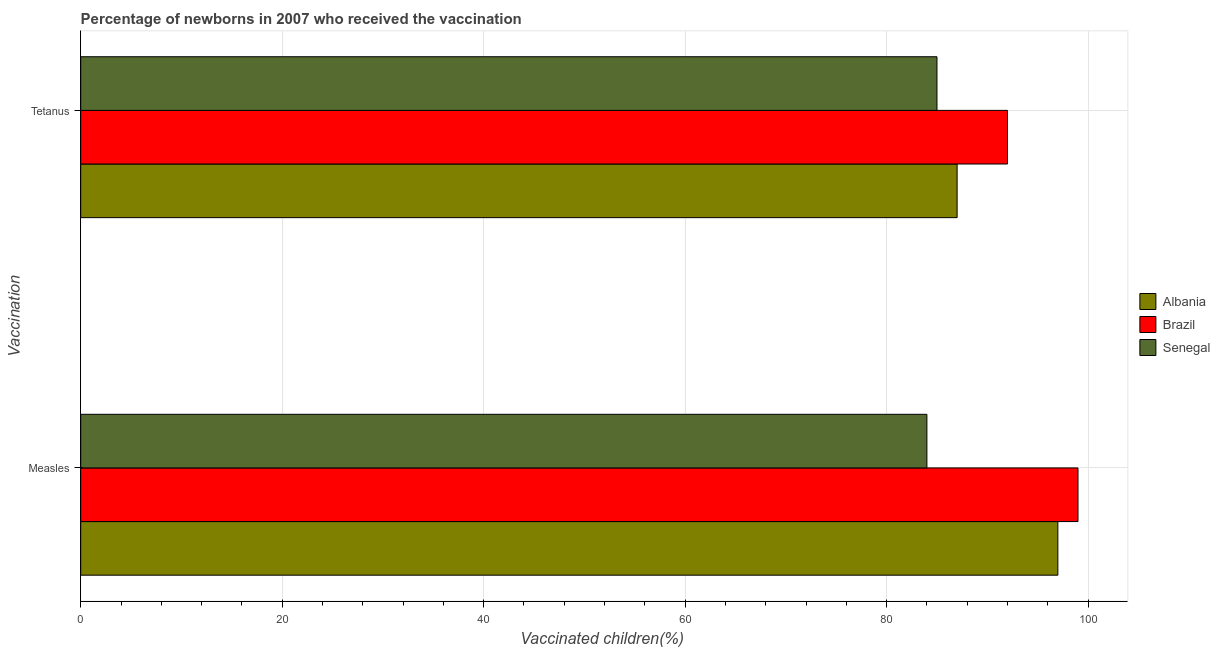Are the number of bars per tick equal to the number of legend labels?
Offer a very short reply. Yes. Are the number of bars on each tick of the Y-axis equal?
Your response must be concise. Yes. What is the label of the 1st group of bars from the top?
Give a very brief answer. Tetanus. What is the percentage of newborns who received vaccination for tetanus in Senegal?
Provide a short and direct response. 85. Across all countries, what is the maximum percentage of newborns who received vaccination for tetanus?
Offer a very short reply. 92. Across all countries, what is the minimum percentage of newborns who received vaccination for measles?
Your answer should be compact. 84. In which country was the percentage of newborns who received vaccination for measles maximum?
Keep it short and to the point. Brazil. In which country was the percentage of newborns who received vaccination for measles minimum?
Offer a terse response. Senegal. What is the total percentage of newborns who received vaccination for tetanus in the graph?
Offer a very short reply. 264. What is the difference between the percentage of newborns who received vaccination for measles in Albania and that in Brazil?
Your response must be concise. -2. What is the difference between the percentage of newborns who received vaccination for measles in Brazil and the percentage of newborns who received vaccination for tetanus in Albania?
Give a very brief answer. 12. What is the average percentage of newborns who received vaccination for tetanus per country?
Offer a terse response. 88. What is the difference between the percentage of newborns who received vaccination for tetanus and percentage of newborns who received vaccination for measles in Brazil?
Give a very brief answer. -7. In how many countries, is the percentage of newborns who received vaccination for measles greater than 64 %?
Make the answer very short. 3. What is the ratio of the percentage of newborns who received vaccination for tetanus in Senegal to that in Brazil?
Your answer should be very brief. 0.92. What does the 3rd bar from the bottom in Tetanus represents?
Your response must be concise. Senegal. How many bars are there?
Offer a very short reply. 6. What is the difference between two consecutive major ticks on the X-axis?
Ensure brevity in your answer.  20. Does the graph contain any zero values?
Keep it short and to the point. No. Does the graph contain grids?
Your answer should be compact. Yes. How are the legend labels stacked?
Your answer should be very brief. Vertical. What is the title of the graph?
Offer a terse response. Percentage of newborns in 2007 who received the vaccination. What is the label or title of the X-axis?
Offer a very short reply. Vaccinated children(%)
. What is the label or title of the Y-axis?
Make the answer very short. Vaccination. What is the Vaccinated children(%)
 of Albania in Measles?
Your answer should be compact. 97. What is the Vaccinated children(%)
 of Brazil in Measles?
Your answer should be very brief. 99. What is the Vaccinated children(%)
 of Albania in Tetanus?
Give a very brief answer. 87. What is the Vaccinated children(%)
 of Brazil in Tetanus?
Your answer should be compact. 92. Across all Vaccination, what is the maximum Vaccinated children(%)
 of Albania?
Ensure brevity in your answer.  97. Across all Vaccination, what is the maximum Vaccinated children(%)
 of Brazil?
Offer a terse response. 99. Across all Vaccination, what is the maximum Vaccinated children(%)
 of Senegal?
Give a very brief answer. 85. Across all Vaccination, what is the minimum Vaccinated children(%)
 of Brazil?
Your answer should be very brief. 92. Across all Vaccination, what is the minimum Vaccinated children(%)
 of Senegal?
Provide a short and direct response. 84. What is the total Vaccinated children(%)
 in Albania in the graph?
Provide a succinct answer. 184. What is the total Vaccinated children(%)
 in Brazil in the graph?
Offer a very short reply. 191. What is the total Vaccinated children(%)
 of Senegal in the graph?
Your answer should be very brief. 169. What is the difference between the Vaccinated children(%)
 of Brazil in Measles and that in Tetanus?
Provide a short and direct response. 7. What is the difference between the Vaccinated children(%)
 of Senegal in Measles and that in Tetanus?
Provide a succinct answer. -1. What is the difference between the Vaccinated children(%)
 of Albania in Measles and the Vaccinated children(%)
 of Brazil in Tetanus?
Your answer should be compact. 5. What is the difference between the Vaccinated children(%)
 of Albania in Measles and the Vaccinated children(%)
 of Senegal in Tetanus?
Your answer should be compact. 12. What is the average Vaccinated children(%)
 in Albania per Vaccination?
Keep it short and to the point. 92. What is the average Vaccinated children(%)
 in Brazil per Vaccination?
Keep it short and to the point. 95.5. What is the average Vaccinated children(%)
 in Senegal per Vaccination?
Your response must be concise. 84.5. What is the difference between the Vaccinated children(%)
 of Albania and Vaccinated children(%)
 of Brazil in Measles?
Your response must be concise. -2. What is the difference between the Vaccinated children(%)
 in Albania and Vaccinated children(%)
 in Senegal in Measles?
Your answer should be compact. 13. What is the difference between the Vaccinated children(%)
 of Albania and Vaccinated children(%)
 of Senegal in Tetanus?
Offer a very short reply. 2. What is the ratio of the Vaccinated children(%)
 in Albania in Measles to that in Tetanus?
Your answer should be very brief. 1.11. What is the ratio of the Vaccinated children(%)
 of Brazil in Measles to that in Tetanus?
Your response must be concise. 1.08. What is the difference between the highest and the second highest Vaccinated children(%)
 in Albania?
Offer a terse response. 10. What is the difference between the highest and the second highest Vaccinated children(%)
 in Brazil?
Provide a short and direct response. 7. What is the difference between the highest and the second highest Vaccinated children(%)
 of Senegal?
Offer a very short reply. 1. 